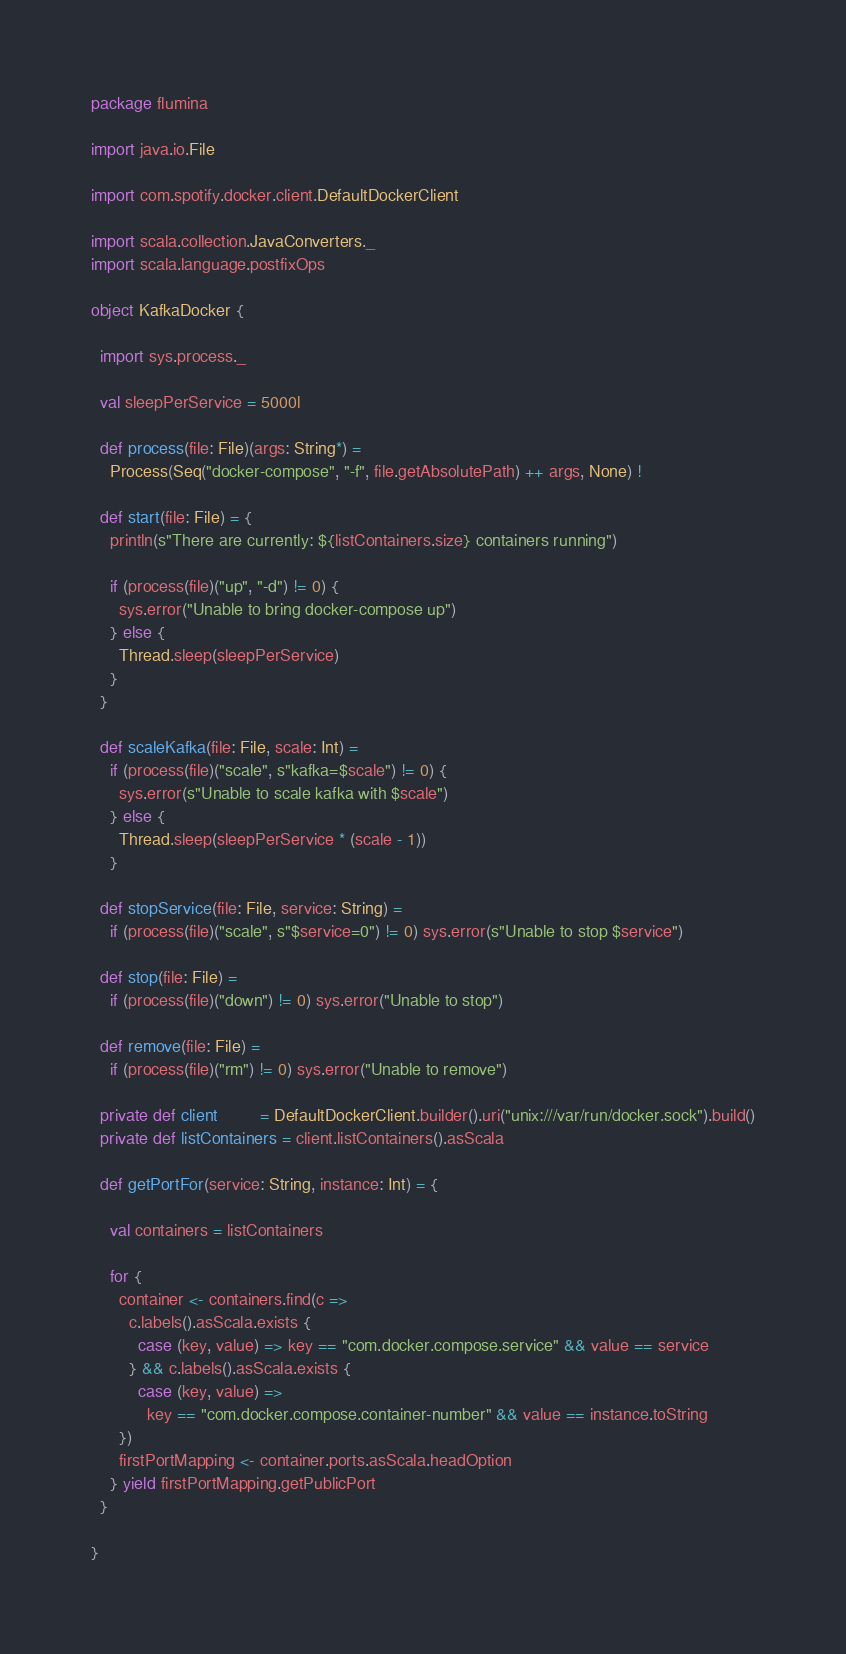<code> <loc_0><loc_0><loc_500><loc_500><_Scala_>package flumina

import java.io.File

import com.spotify.docker.client.DefaultDockerClient

import scala.collection.JavaConverters._
import scala.language.postfixOps

object KafkaDocker {

  import sys.process._

  val sleepPerService = 5000l

  def process(file: File)(args: String*) =
    Process(Seq("docker-compose", "-f", file.getAbsolutePath) ++ args, None) !

  def start(file: File) = {
    println(s"There are currently: ${listContainers.size} containers running")

    if (process(file)("up", "-d") != 0) {
      sys.error("Unable to bring docker-compose up")
    } else {
      Thread.sleep(sleepPerService)
    }
  }

  def scaleKafka(file: File, scale: Int) =
    if (process(file)("scale", s"kafka=$scale") != 0) {
      sys.error(s"Unable to scale kafka with $scale")
    } else {
      Thread.sleep(sleepPerService * (scale - 1))
    }

  def stopService(file: File, service: String) =
    if (process(file)("scale", s"$service=0") != 0) sys.error(s"Unable to stop $service")

  def stop(file: File) =
    if (process(file)("down") != 0) sys.error("Unable to stop")

  def remove(file: File) =
    if (process(file)("rm") != 0) sys.error("Unable to remove")

  private def client         = DefaultDockerClient.builder().uri("unix:///var/run/docker.sock").build()
  private def listContainers = client.listContainers().asScala

  def getPortFor(service: String, instance: Int) = {

    val containers = listContainers

    for {
      container <- containers.find(c =>
        c.labels().asScala.exists {
          case (key, value) => key == "com.docker.compose.service" && value == service
        } && c.labels().asScala.exists {
          case (key, value) =>
            key == "com.docker.compose.container-number" && value == instance.toString
      })
      firstPortMapping <- container.ports.asScala.headOption
    } yield firstPortMapping.getPublicPort
  }

}
</code> 